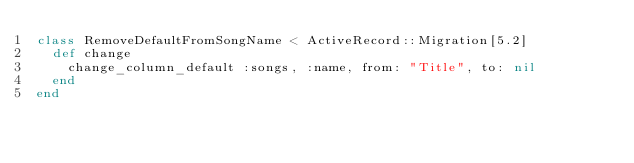<code> <loc_0><loc_0><loc_500><loc_500><_Ruby_>class RemoveDefaultFromSongName < ActiveRecord::Migration[5.2]
  def change
    change_column_default :songs, :name, from: "Title", to: nil
  end
end
</code> 